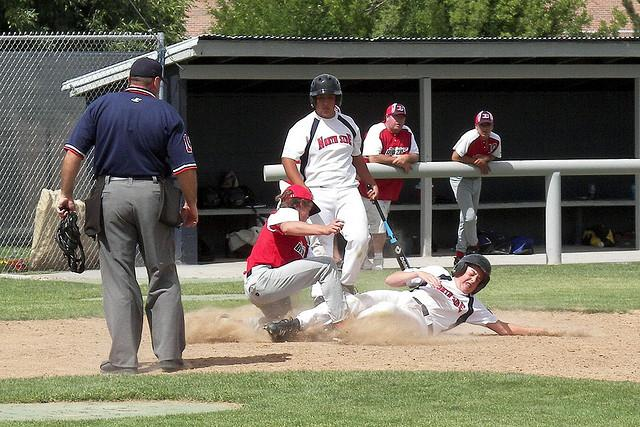Who famously helped win a 1992 playoff game doing what the boy in the black helmet is doing? Please explain your reasoning. sid bream. Sid bream helped win the game. 